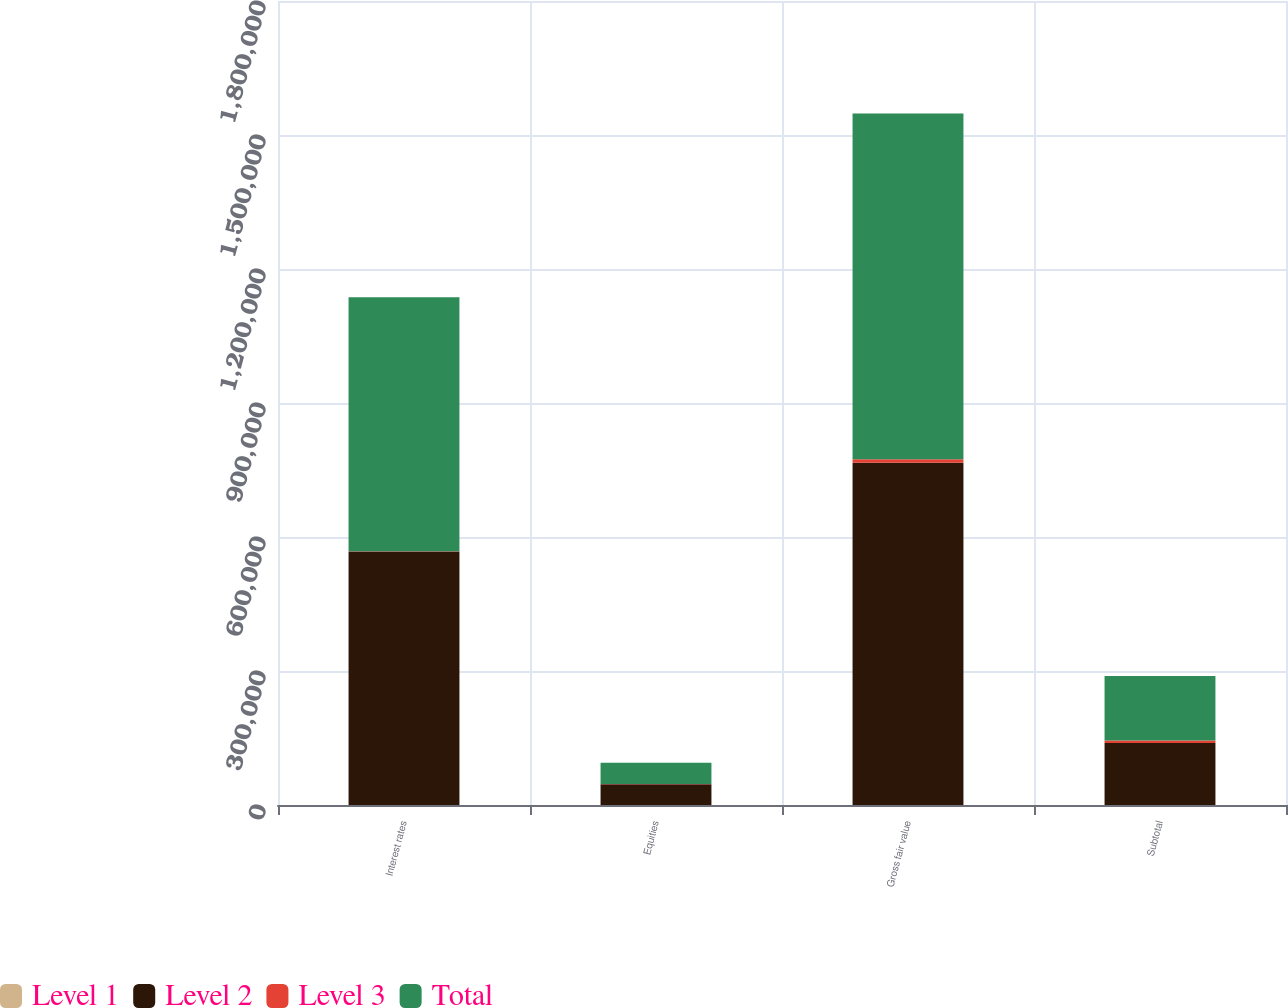Convert chart to OTSL. <chart><loc_0><loc_0><loc_500><loc_500><stacked_bar_chart><ecel><fcel>Interest rates<fcel>Equities<fcel>Gross fair value<fcel>Subtotal<nl><fcel>Level 1<fcel>4<fcel>46<fcel>50<fcel>50<nl><fcel>Level 2<fcel>567761<fcel>46491<fcel>766130<fcel>138582<nl><fcel>Level 3<fcel>560<fcel>623<fcel>8009<fcel>5870<nl><fcel>Total<fcel>568325<fcel>47160<fcel>774189<fcel>144502<nl></chart> 